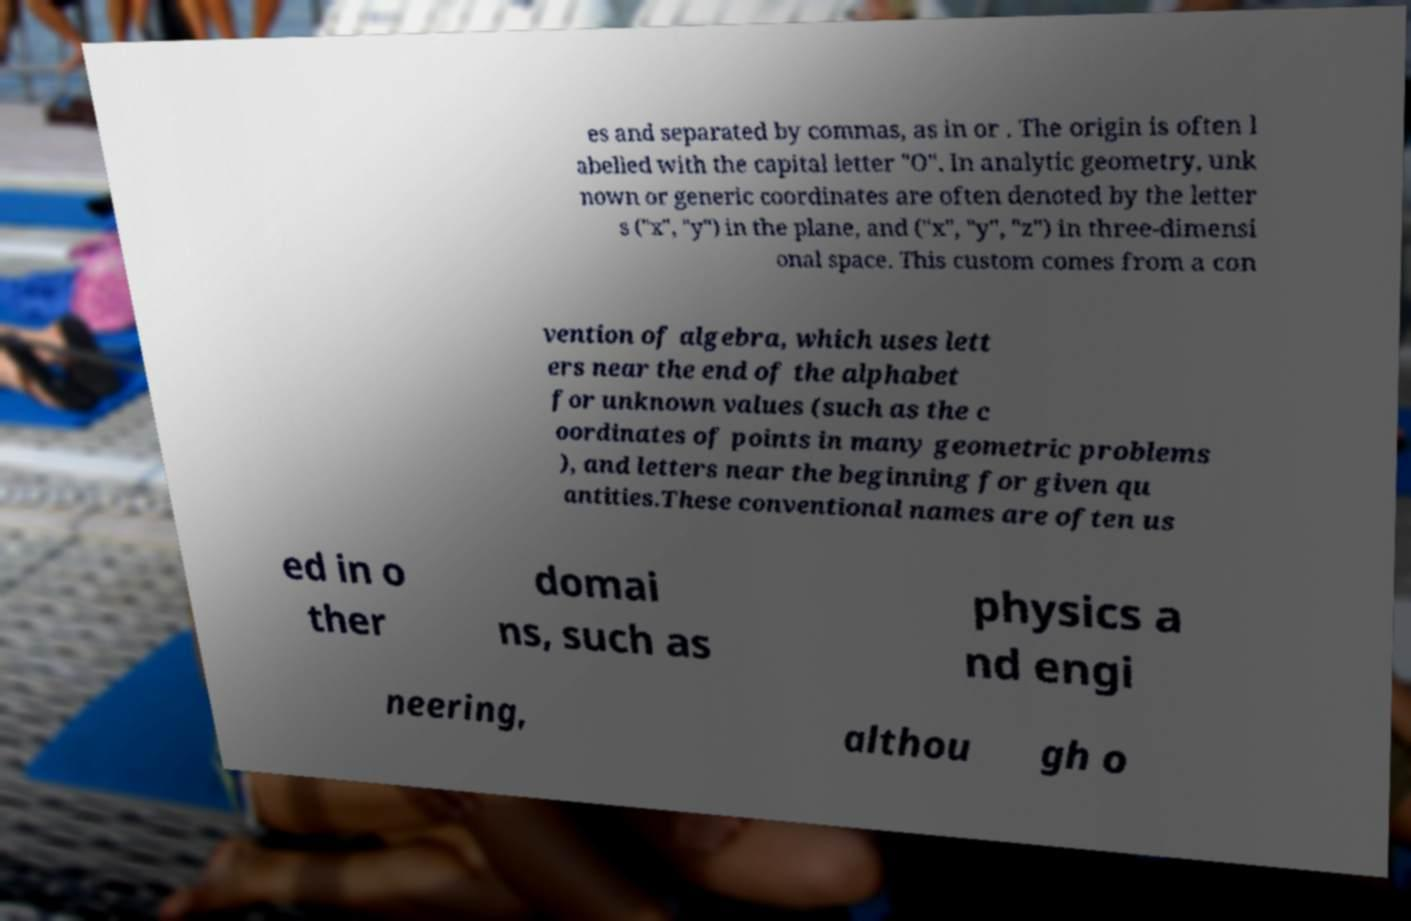I need the written content from this picture converted into text. Can you do that? es and separated by commas, as in or . The origin is often l abelled with the capital letter "O". In analytic geometry, unk nown or generic coordinates are often denoted by the letter s ("x", "y") in the plane, and ("x", "y", "z") in three-dimensi onal space. This custom comes from a con vention of algebra, which uses lett ers near the end of the alphabet for unknown values (such as the c oordinates of points in many geometric problems ), and letters near the beginning for given qu antities.These conventional names are often us ed in o ther domai ns, such as physics a nd engi neering, althou gh o 